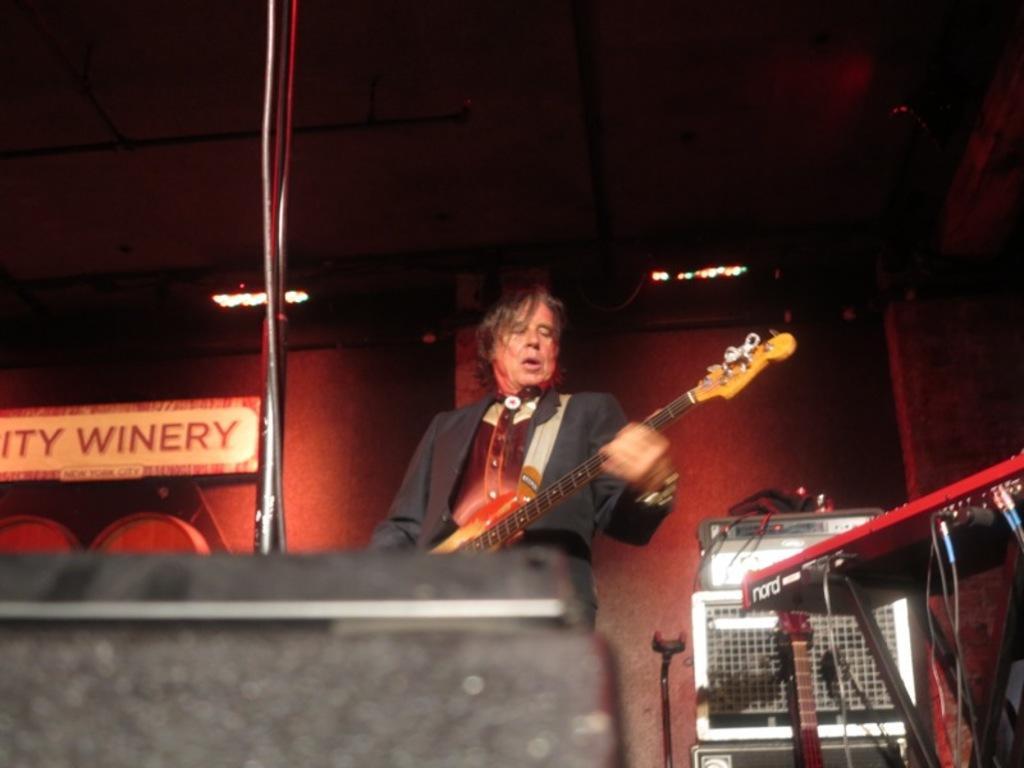Can you describe this image briefly? In the center of the image there is a person holding a guitar. In the background of the image there is wall. To the right side of the image there is a musical instrument. At the top of the image there is a ceiling. 